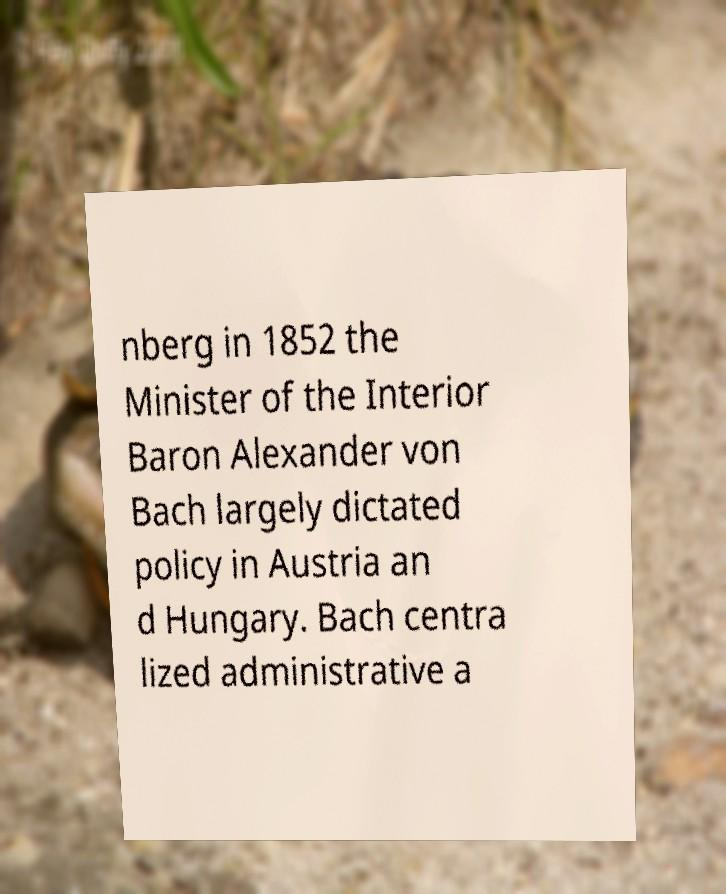Please identify and transcribe the text found in this image. nberg in 1852 the Minister of the Interior Baron Alexander von Bach largely dictated policy in Austria an d Hungary. Bach centra lized administrative a 